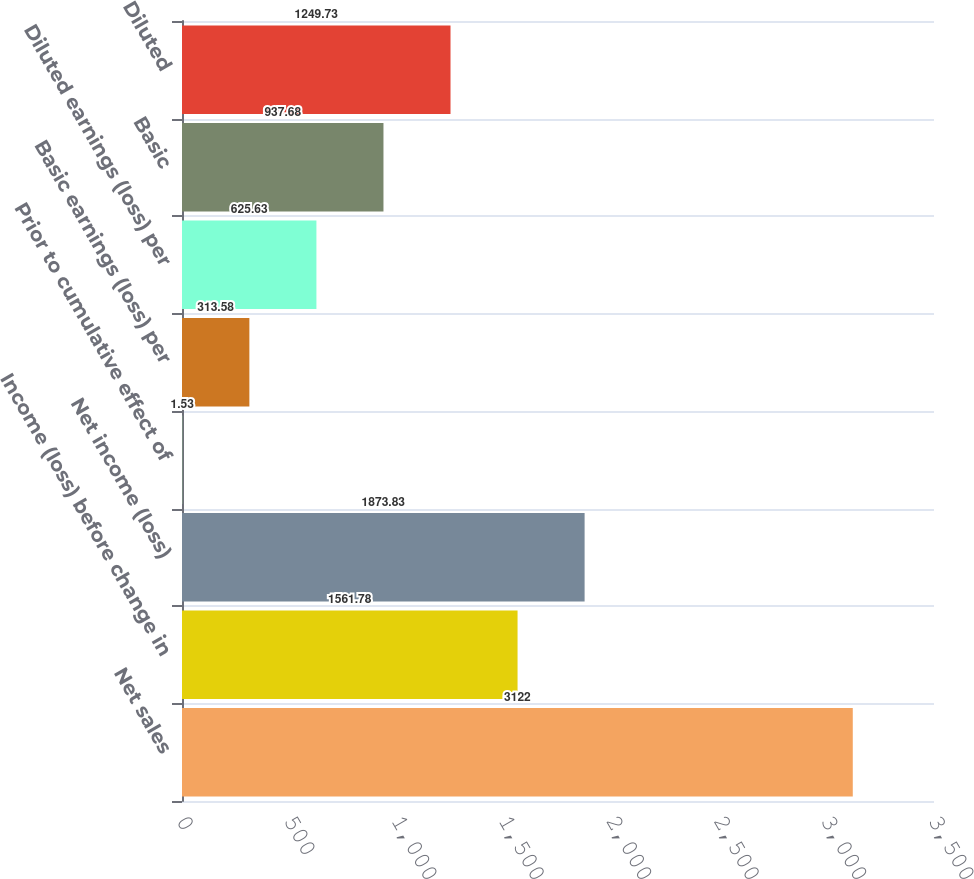Convert chart. <chart><loc_0><loc_0><loc_500><loc_500><bar_chart><fcel>Net sales<fcel>Income (loss) before change in<fcel>Net income (loss)<fcel>Prior to cumulative effect of<fcel>Basic earnings (loss) per<fcel>Diluted earnings (loss) per<fcel>Basic<fcel>Diluted<nl><fcel>3122<fcel>1561.78<fcel>1873.83<fcel>1.53<fcel>313.58<fcel>625.63<fcel>937.68<fcel>1249.73<nl></chart> 